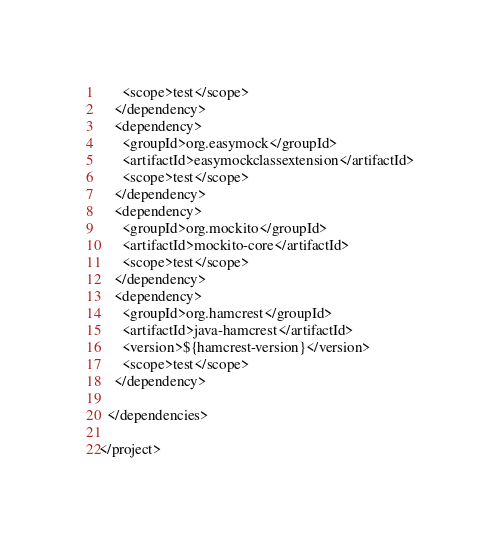<code> <loc_0><loc_0><loc_500><loc_500><_XML_>      <scope>test</scope>
    </dependency>
    <dependency>
      <groupId>org.easymock</groupId>
      <artifactId>easymockclassextension</artifactId>
      <scope>test</scope>
    </dependency>
    <dependency>
      <groupId>org.mockito</groupId>
      <artifactId>mockito-core</artifactId>
      <scope>test</scope>
    </dependency>
    <dependency>
      <groupId>org.hamcrest</groupId>
      <artifactId>java-hamcrest</artifactId>
      <version>${hamcrest-version}</version>
      <scope>test</scope>
    </dependency>

  </dependencies>

</project>
</code> 